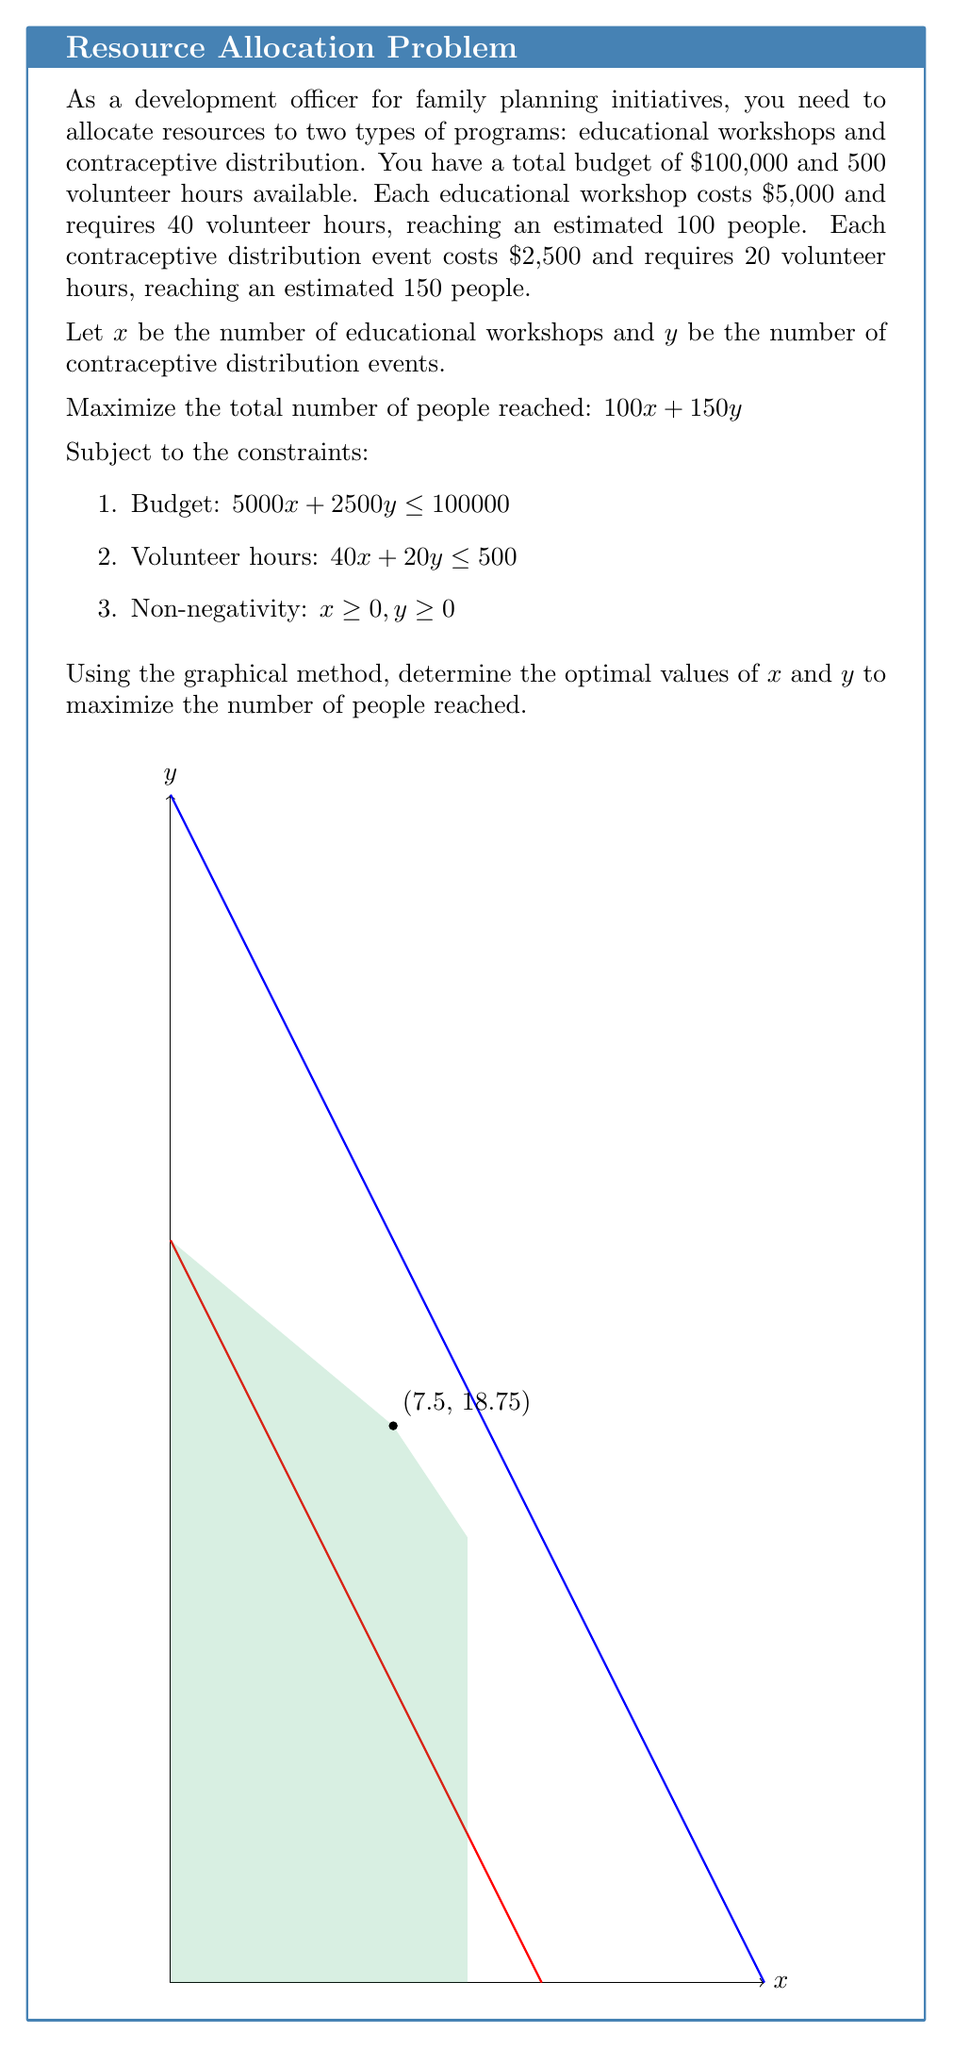Teach me how to tackle this problem. Let's solve this problem step-by-step using the graphical method:

1) First, let's graph the constraints:

   a) Budget constraint: $5000x + 2500y \leq 100000$
      Simplify: $2x + y \leq 40$
      x-intercept: (20, 0), y-intercept: (0, 40)

   b) Volunteer hours constraint: $40x + 20y \leq 500$
      Simplify: $2x + y \leq 25$
      x-intercept: (12.5, 0), y-intercept: (0, 25)

2) The feasible region is the area that satisfies both constraints and the non-negativity conditions. It's the green shaded area in the graph.

3) The corners of the feasible region are the potential optimal points. They are:
   (0, 0), (0, 25), (7.5, 18.75), (10, 15), (12.5, 0)

4) Now, let's evaluate the objective function $Z = 100x + 150y$ at each point:

   (0, 0):      Z = 0
   (0, 25):     Z = 3,750
   (7.5, 18.75): Z = 3,562.5
   (10, 15):    Z = 3,250
   (12.5, 0):   Z = 1,250

5) The maximum value is achieved at the point (7.5, 18.75).

6) Therefore, the optimal solution is:
   x = 7.5 (educational workshops)
   y = 18.75 (contraceptive distribution events)

7) This solution will reach:
   100(7.5) + 150(18.75) = 750 + 2,812.5 = 3,562.5 people

8) In practice, we would round down to 7 educational workshops and 18 contraceptive distribution events, reaching 3,450 people.
Answer: 7 educational workshops, 18 contraceptive distribution events 